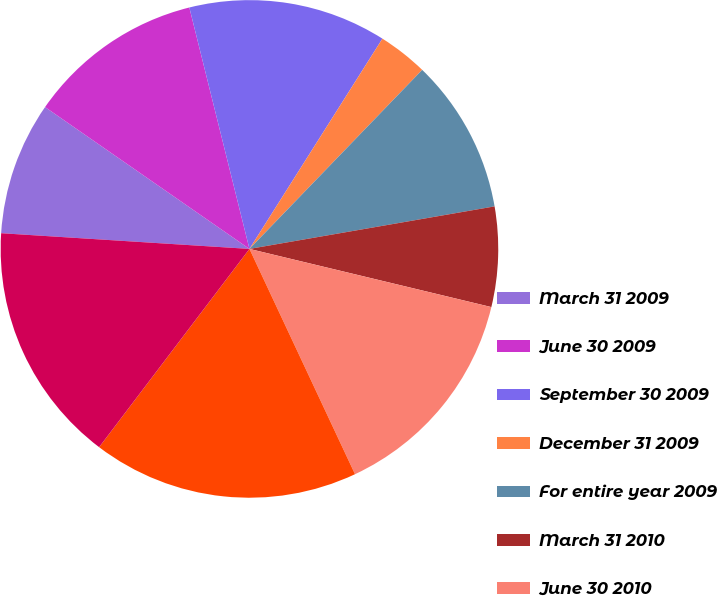Convert chart. <chart><loc_0><loc_0><loc_500><loc_500><pie_chart><fcel>March 31 2009<fcel>June 30 2009<fcel>September 30 2009<fcel>December 31 2009<fcel>For entire year 2009<fcel>March 31 2010<fcel>June 30 2010<fcel>September 30 2010<fcel>For entire year 2010<nl><fcel>8.65%<fcel>11.46%<fcel>12.86%<fcel>3.24%<fcel>10.05%<fcel>6.49%<fcel>14.27%<fcel>17.3%<fcel>15.68%<nl></chart> 